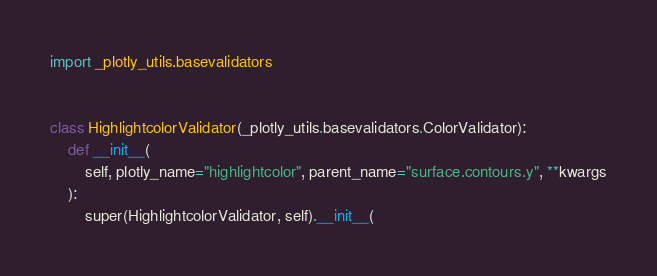Convert code to text. <code><loc_0><loc_0><loc_500><loc_500><_Python_>import _plotly_utils.basevalidators


class HighlightcolorValidator(_plotly_utils.basevalidators.ColorValidator):
    def __init__(
        self, plotly_name="highlightcolor", parent_name="surface.contours.y", **kwargs
    ):
        super(HighlightcolorValidator, self).__init__(</code> 